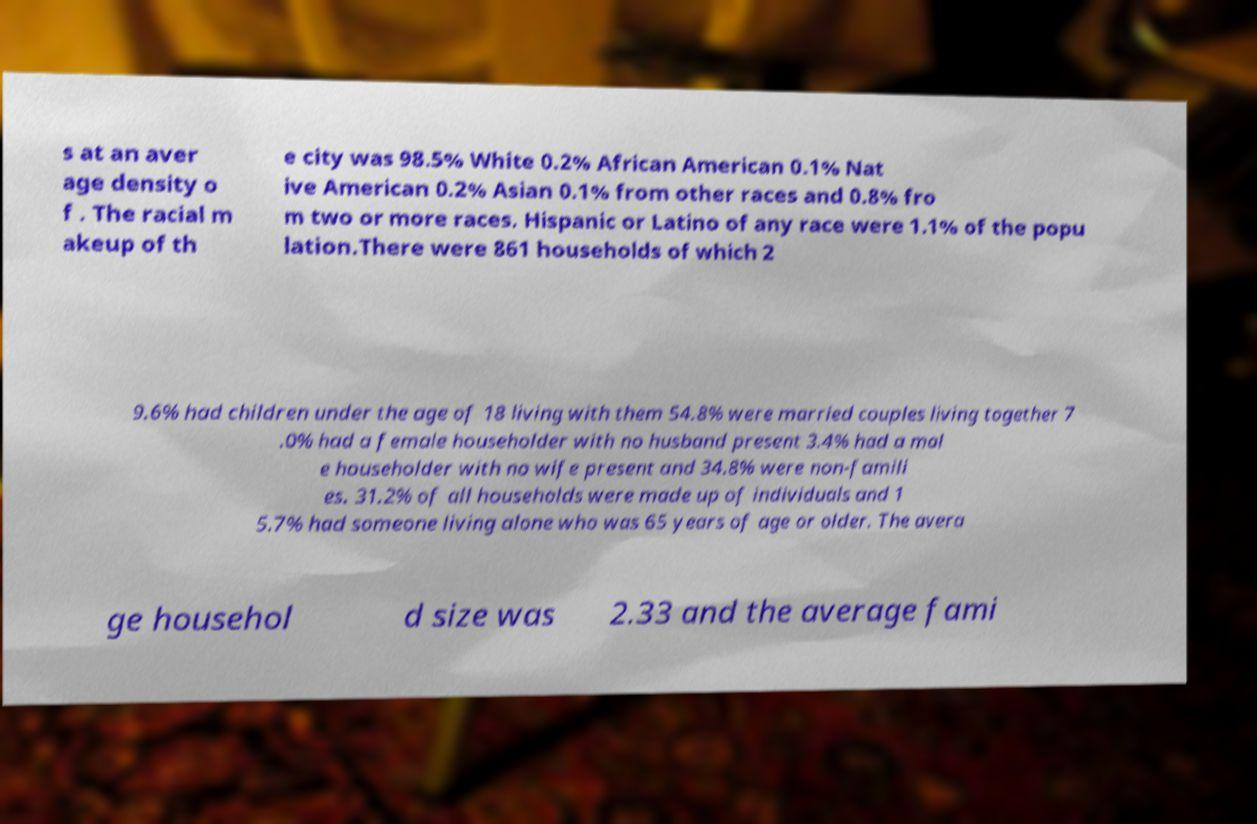Could you extract and type out the text from this image? s at an aver age density o f . The racial m akeup of th e city was 98.5% White 0.2% African American 0.1% Nat ive American 0.2% Asian 0.1% from other races and 0.8% fro m two or more races. Hispanic or Latino of any race were 1.1% of the popu lation.There were 861 households of which 2 9.6% had children under the age of 18 living with them 54.8% were married couples living together 7 .0% had a female householder with no husband present 3.4% had a mal e householder with no wife present and 34.8% were non-famili es. 31.2% of all households were made up of individuals and 1 5.7% had someone living alone who was 65 years of age or older. The avera ge househol d size was 2.33 and the average fami 